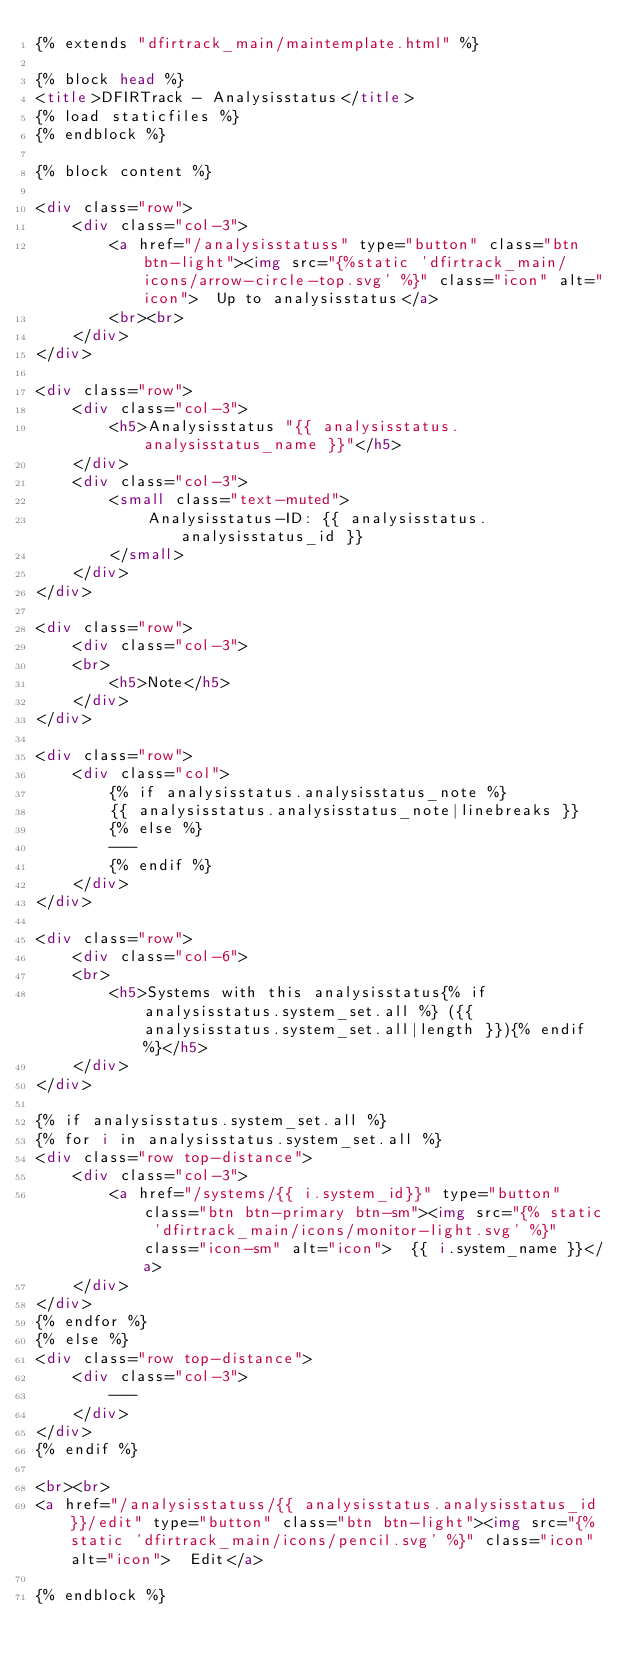<code> <loc_0><loc_0><loc_500><loc_500><_HTML_>{% extends "dfirtrack_main/maintemplate.html" %}

{% block head %}
<title>DFIRTrack - Analysisstatus</title>
{% load staticfiles %}
{% endblock %}

{% block content %}

<div class="row">
    <div class="col-3">
        <a href="/analysisstatuss" type="button" class="btn btn-light"><img src="{%static 'dfirtrack_main/icons/arrow-circle-top.svg' %}" class="icon" alt="icon">  Up to analysisstatus</a>
        <br><br>
    </div>
</div>

<div class="row">
    <div class="col-3">
        <h5>Analysisstatus "{{ analysisstatus.analysisstatus_name }}"</h5>
    </div>
    <div class="col-3">
        <small class="text-muted">
            Analysisstatus-ID: {{ analysisstatus.analysisstatus_id }}
        </small>
    </div>
</div>

<div class="row">
    <div class="col-3">
    <br>
        <h5>Note</h5>
    </div>
</div>

<div class="row">
    <div class="col">
        {% if analysisstatus.analysisstatus_note %}
        {{ analysisstatus.analysisstatus_note|linebreaks }}
        {% else %}
        ---
        {% endif %}
    </div>
</div>

<div class="row">
    <div class="col-6">
    <br>
        <h5>Systems with this analysisstatus{% if analysisstatus.system_set.all %} ({{ analysisstatus.system_set.all|length }}){% endif %}</h5>
    </div>
</div>

{% if analysisstatus.system_set.all %}
{% for i in analysisstatus.system_set.all %}
<div class="row top-distance">
    <div class="col-3">
        <a href="/systems/{{ i.system_id}}" type="button" class="btn btn-primary btn-sm"><img src="{% static 'dfirtrack_main/icons/monitor-light.svg' %}" class="icon-sm" alt="icon">  {{ i.system_name }}</a>
    </div>
</div>
{% endfor %}
{% else %}
<div class="row top-distance">
    <div class="col-3">
        ---
    </div>
</div>
{% endif %}

<br><br>
<a href="/analysisstatuss/{{ analysisstatus.analysisstatus_id }}/edit" type="button" class="btn btn-light"><img src="{% static 'dfirtrack_main/icons/pencil.svg' %}" class="icon" alt="icon">  Edit</a>

{% endblock %}
</code> 